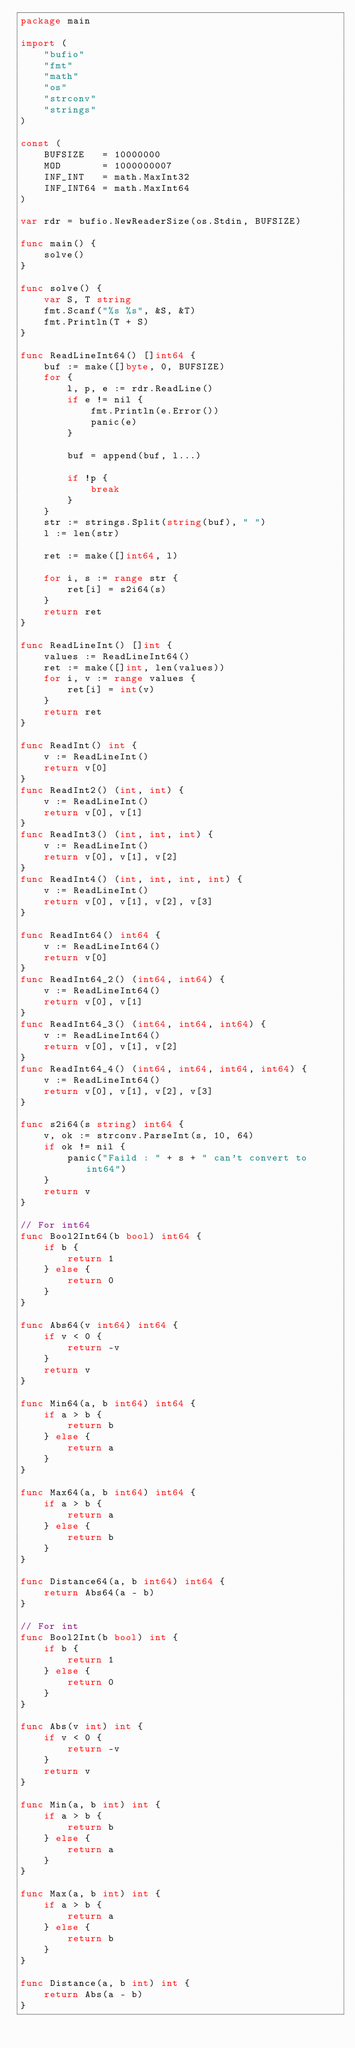Convert code to text. <code><loc_0><loc_0><loc_500><loc_500><_Go_>package main

import (
	"bufio"
	"fmt"
	"math"
	"os"
	"strconv"
	"strings"
)

const (
	BUFSIZE   = 10000000
	MOD       = 1000000007
	INF_INT   = math.MaxInt32
	INF_INT64 = math.MaxInt64
)

var rdr = bufio.NewReaderSize(os.Stdin, BUFSIZE)

func main() {
	solve()
}

func solve() {
	var S, T string
	fmt.Scanf("%s %s", &S, &T)
	fmt.Println(T + S)
}

func ReadLineInt64() []int64 {
	buf := make([]byte, 0, BUFSIZE)
	for {
		l, p, e := rdr.ReadLine()
		if e != nil {
			fmt.Println(e.Error())
			panic(e)
		}

		buf = append(buf, l...)

		if !p {
			break
		}
	}
	str := strings.Split(string(buf), " ")
	l := len(str)

	ret := make([]int64, l)

	for i, s := range str {
		ret[i] = s2i64(s)
	}
	return ret
}

func ReadLineInt() []int {
	values := ReadLineInt64()
	ret := make([]int, len(values))
	for i, v := range values {
		ret[i] = int(v)
	}
	return ret
}

func ReadInt() int {
	v := ReadLineInt()
	return v[0]
}
func ReadInt2() (int, int) {
	v := ReadLineInt()
	return v[0], v[1]
}
func ReadInt3() (int, int, int) {
	v := ReadLineInt()
	return v[0], v[1], v[2]
}
func ReadInt4() (int, int, int, int) {
	v := ReadLineInt()
	return v[0], v[1], v[2], v[3]
}

func ReadInt64() int64 {
	v := ReadLineInt64()
	return v[0]
}
func ReadInt64_2() (int64, int64) {
	v := ReadLineInt64()
	return v[0], v[1]
}
func ReadInt64_3() (int64, int64, int64) {
	v := ReadLineInt64()
	return v[0], v[1], v[2]
}
func ReadInt64_4() (int64, int64, int64, int64) {
	v := ReadLineInt64()
	return v[0], v[1], v[2], v[3]
}

func s2i64(s string) int64 {
	v, ok := strconv.ParseInt(s, 10, 64)
	if ok != nil {
		panic("Faild : " + s + " can't convert to int64")
	}
	return v
}

// For int64
func Bool2Int64(b bool) int64 {
	if b {
		return 1
	} else {
		return 0
	}
}

func Abs64(v int64) int64 {
	if v < 0 {
		return -v
	}
	return v
}

func Min64(a, b int64) int64 {
	if a > b {
		return b
	} else {
		return a
	}
}

func Max64(a, b int64) int64 {
	if a > b {
		return a
	} else {
		return b
	}
}

func Distance64(a, b int64) int64 {
	return Abs64(a - b)
}

// For int
func Bool2Int(b bool) int {
	if b {
		return 1
	} else {
		return 0
	}
}

func Abs(v int) int {
	if v < 0 {
		return -v
	}
	return v
}

func Min(a, b int) int {
	if a > b {
		return b
	} else {
		return a
	}
}

func Max(a, b int) int {
	if a > b {
		return a
	} else {
		return b
	}
}

func Distance(a, b int) int {
	return Abs(a - b)
}
</code> 